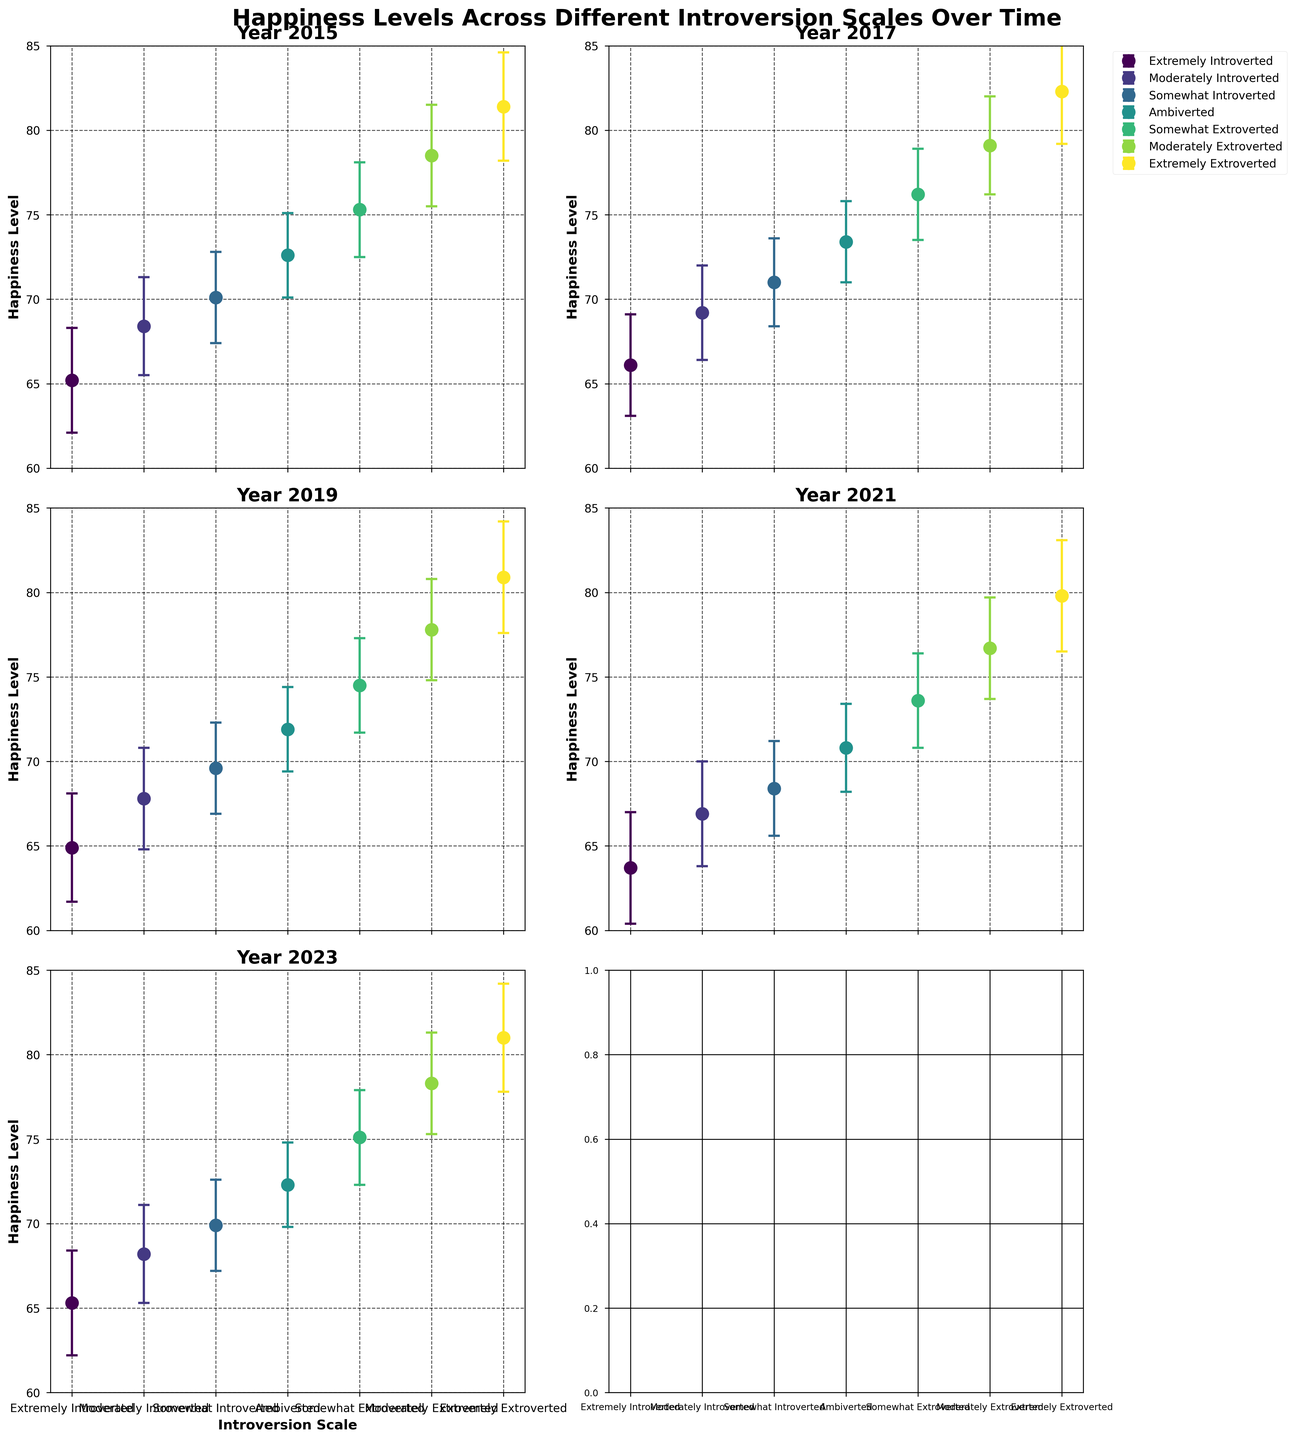What is the title of the figure? The title of the figure is usually located at the top center of the plot. According to the provided code, the title is set using "fig.suptitle". From there, we can see that the title is 'Happiness Levels Across Different Introversion Scales Over Time'.
Answer: Happiness Levels Across Different Introversion Scales Over Time How many subplots are there in the figure? The figure grid is established by the statement "fig, axs = plt.subplots(3, 2)", which generates a 3x2 grid of subplots. This results in a total of 3 rows and 2 columns.
Answer: 6 What is represented by the y-axis in each subplot? According to the provided code, the y-axis label is set to 'Happiness Level' by "ax.set_ylabel('Happiness Level', ...)". Thus, the y-axis represents happiness levels.
Answer: Happiness Level How does the happiness level of 'Ambiverted' individuals change from 2015 to 2023? To find the change, we look at the happiness levels for 'Ambiverted' individuals in each subplot from 2015 to 2023. According to the data:
- 2015: 72.6
- 2017: 73.4
- 2019: 71.9
- 2021: 70.8
- 2023: 72.3
The happiness level slightly increases from 72.6 in 2015 to 72.3 in 2023.
Answer: Slightly decreases Which introversion scale consistently shows the highest happiness level across the years? By examining each subplot, we can see that 'Extremely Extroverted' individuals consistently have the highest values in each year. This is due to their happiness levels being:
- 2015: 81.4
- 2017: 82.3
- 2019: 80.9
- 2021: 79.8
- 2023: 81.0
Thus, 'Extremely Extroverted' individuals have the highest happiness levels.
Answer: Extremely Extroverted What is the overall trend in happiness levels for 'Extremely Introverted' individuals from 2015 to 2023? Looking at the data points for 'Extremely Introverted' individuals, their happiness levels are:
- 2015: 65.2
- 2017: 66.1
- 2019: 64.9
- 2021: 63.7
- 2023: 65.3
The overall trend shows a minor decrease with slight fluctuations over the years.
Answer: Slight decrease Among the years displayed, in which year is the happiness level the lowest for 'Moderately Introverted' individuals? We look at the happiness levels for 'Moderately Introverted' individuals across the years:
- 2015: 68.4
- 2017: 69.2
- 2019: 67.8
- 2021: 66.9
- 2023: 68.2
The lowest happiness level for 'Moderately Introverted' individuals is in 2021.
Answer: 2021 In which year is the difference in happiness levels between 'Extremely Extroverted' and 'Extremely Introverted' individuals the greatest? To determine this, we calculate the difference for each year:
- 2015: 81.4 - 65.2 = 16.2
- 2017: 82.3 - 66.1 = 16.2
- 2019: 80.9 - 64.9 = 16.0
- 2021: 79.8 - 63.7 = 16.1
- 2023: 81.0 - 65.3 = 15.7
The greatest difference is in the years 2015 and 2017, both having 16.2.
Answer: 2015 and 2017 